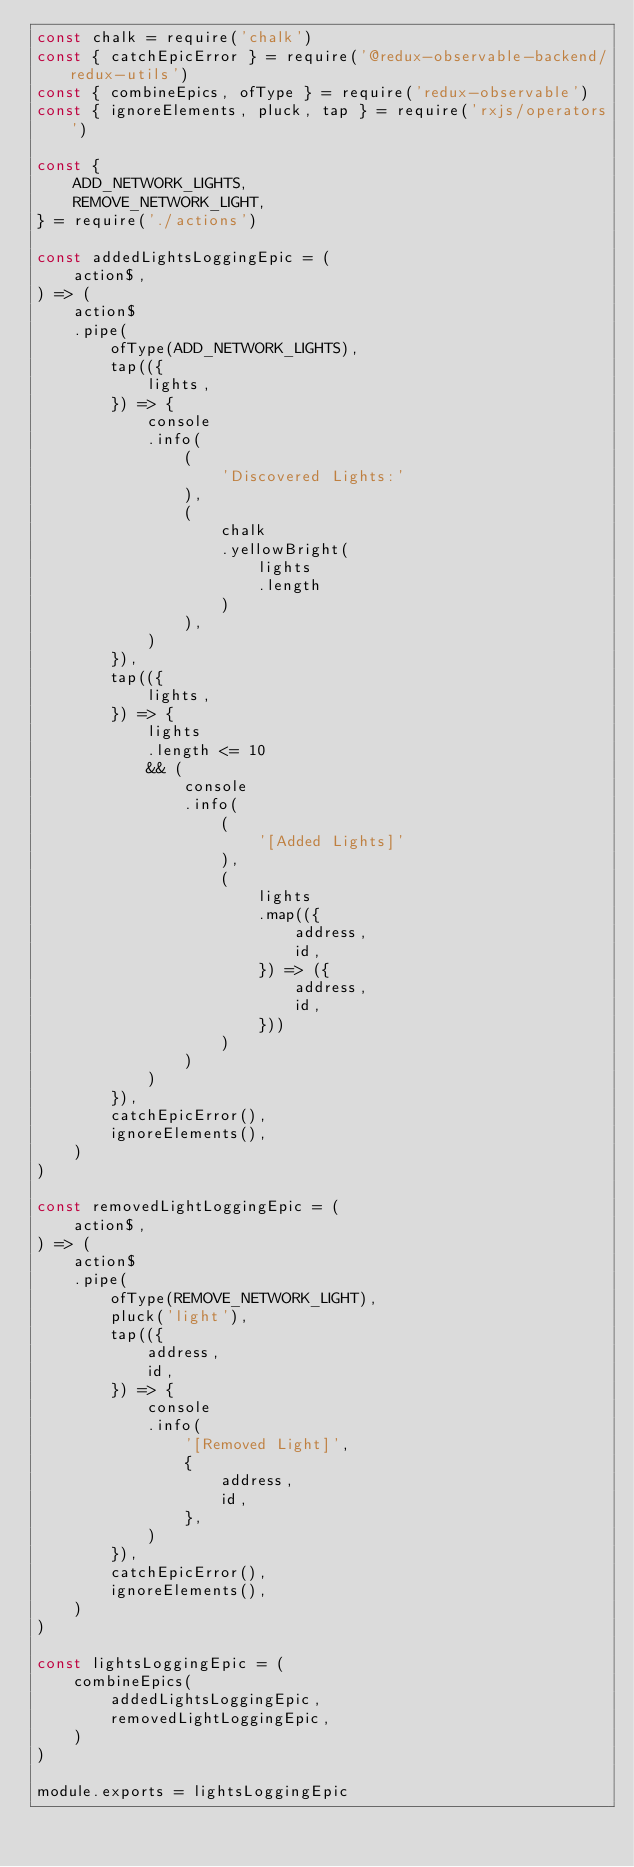<code> <loc_0><loc_0><loc_500><loc_500><_JavaScript_>const chalk = require('chalk')
const { catchEpicError } = require('@redux-observable-backend/redux-utils')
const { combineEpics, ofType } = require('redux-observable')
const { ignoreElements, pluck, tap } = require('rxjs/operators')

const {
	ADD_NETWORK_LIGHTS,
	REMOVE_NETWORK_LIGHT,
} = require('./actions')

const addedLightsLoggingEpic = (
	action$,
) => (
	action$
	.pipe(
		ofType(ADD_NETWORK_LIGHTS),
		tap(({
			lights,
		}) => {
			console
			.info(
				(
					'Discovered Lights:'
				),
				(
					chalk
					.yellowBright(
						lights
						.length
					)
				),
			)
		}),
		tap(({
			lights,
		}) => {
			lights
			.length <= 10
			&& (
				console
				.info(
					(
						'[Added Lights]'
					),
					(
						lights
						.map(({
							address,
							id,
						}) => ({
							address,
							id,
						}))
					)
				)
			)
		}),
		catchEpicError(),
		ignoreElements(),
	)
)

const removedLightLoggingEpic = (
	action$,
) => (
	action$
	.pipe(
		ofType(REMOVE_NETWORK_LIGHT),
		pluck('light'),
		tap(({
			address,
			id,
		}) => {
			console
			.info(
				'[Removed Light]',
				{
					address,
					id,
				},
			)
		}),
		catchEpicError(),
		ignoreElements(),
	)
)

const lightsLoggingEpic = (
	combineEpics(
		addedLightsLoggingEpic,
		removedLightLoggingEpic,
	)
)

module.exports = lightsLoggingEpic
</code> 